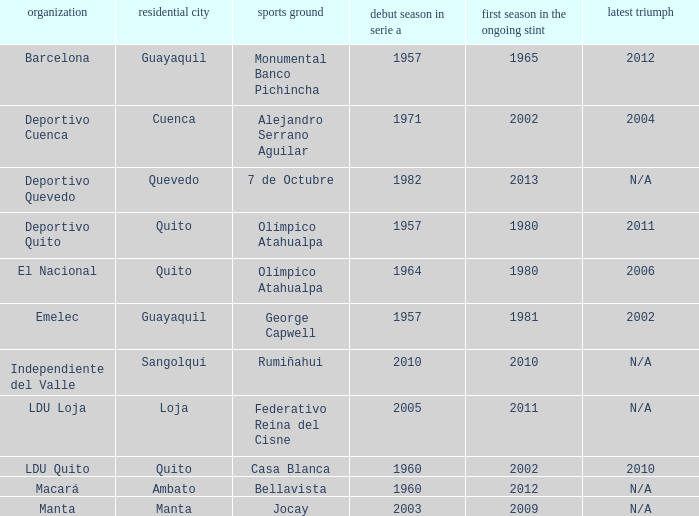Name the first season in the series for 2006 1964.0. 